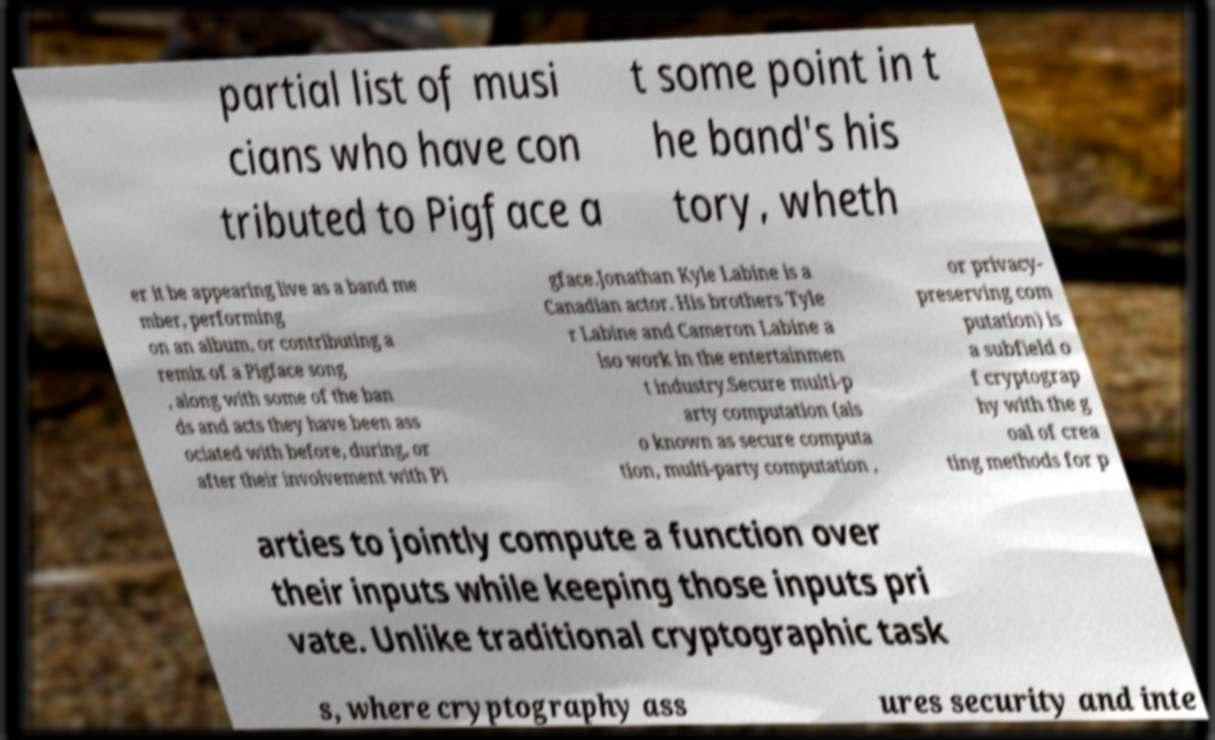For documentation purposes, I need the text within this image transcribed. Could you provide that? partial list of musi cians who have con tributed to Pigface a t some point in t he band's his tory, wheth er it be appearing live as a band me mber, performing on an album, or contributing a remix of a Pigface song , along with some of the ban ds and acts they have been ass ociated with before, during, or after their involvement with Pi gface.Jonathan Kyle Labine is a Canadian actor. His brothers Tyle r Labine and Cameron Labine a lso work in the entertainmen t industry.Secure multi-p arty computation (als o known as secure computa tion, multi-party computation , or privacy- preserving com putation) is a subfield o f cryptograp hy with the g oal of crea ting methods for p arties to jointly compute a function over their inputs while keeping those inputs pri vate. Unlike traditional cryptographic task s, where cryptography ass ures security and inte 